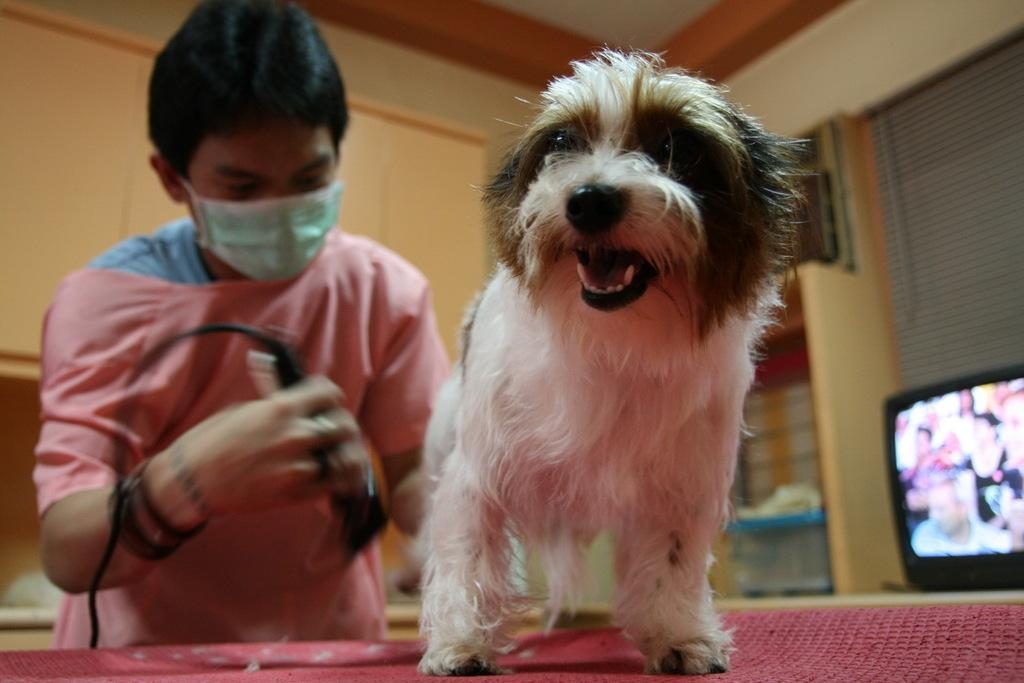What animal is on the table in the image? There is a dog on a table in the image. Who is present in the image besides the dog? There is a person behind the dog. What is the person holding in his hand? The person is holding a trimmer in his hand. What can be seen behind the dog? There is a television behind the dog. How many stamps are on the dog in the image? There are no stamps visible on the dog in the image. Can you describe the rabbit that is sitting next to the television? There is no rabbit present in the image; only the dog, person, trimmer, and television are visible. 